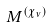<formula> <loc_0><loc_0><loc_500><loc_500>M ^ { ( \chi _ { \nu } ) }</formula> 